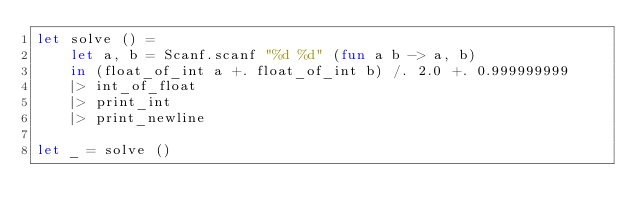<code> <loc_0><loc_0><loc_500><loc_500><_OCaml_>let solve () =
    let a, b = Scanf.scanf "%d %d" (fun a b -> a, b)
    in (float_of_int a +. float_of_int b) /. 2.0 +. 0.999999999
    |> int_of_float
    |> print_int
    |> print_newline

let _ = solve ()</code> 